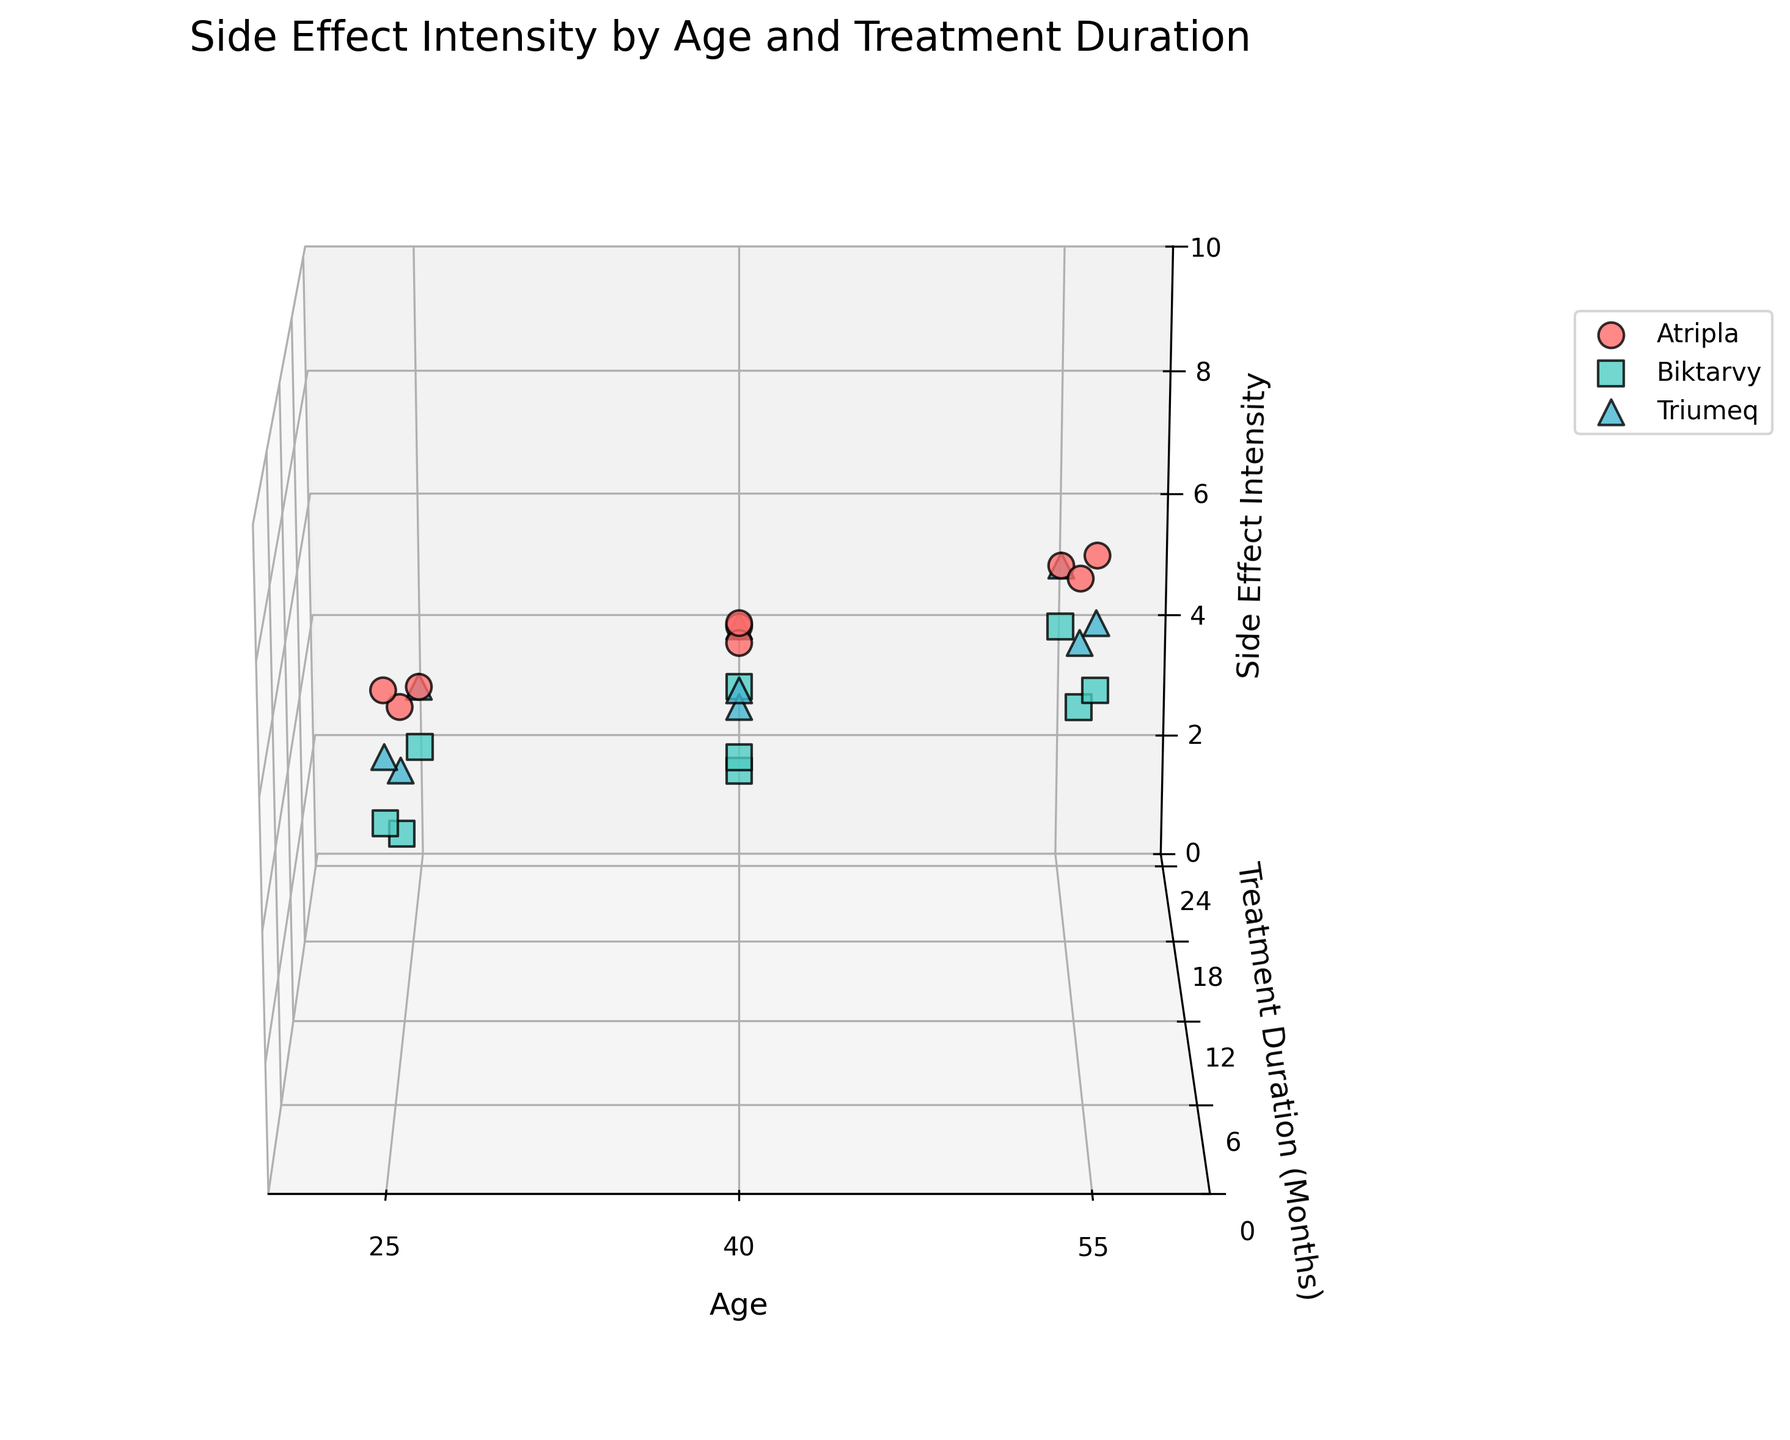What's the title of the figure? The title is typically placed at the top of the figure in a readable font size. The title of this figure is explicitly stated in the code as "Side Effect Intensity by Age and Treatment Duration."
Answer: Side Effect Intensity by Age and Treatment Duration What data does the x-axis represent? From the labels set in the code, the x-axis represents "Age" of the patients. This label helps to interpret what is being compared or measured.
Answer: Age What pattern can you observe with Side Effect Intensity over Treatment Duration for Atripla? The data suggests a decreasing trend of Side Effect Intensity over Treatment Duration for Atripla. Observing the plot points, Atripla shows higher side effect intensities at 3 months which decrease progressively over 12 and 24 months.
Answer: Decreasing trend Which medication seems to have the lowest overall Side Effect Intensity? By comparing the colored points, Biktarvy, represented by a specific color (e.g., turquoise), generally lies lower on the z-axis for all age groups and treatment durations.
Answer: Biktarvy How does the Side Effect Intensity for Triumeq change with the age of patients after 24 months of treatment? At 24 months, the z-coordinates for Triumeq's different ages (25, 40, 55) can be observed, which increase gradually as the age increases. This shows a pattern of side effects increasing with age.
Answer: Increases with age Which age group appears to be the most affected by Atripla in the early stage (3 months)? Look at the z-coordinates (Side Effect Intensity) for Atripla at 3 months across different ages. The 55-year-old group has the highest point, indicating they are most affected early on.
Answer: 55-year-olds What is the difference in Side Effect Intensity at 12 months between the youngest and oldest age groups for Biktarvy? For Biktarvy, note the z-values at 12 months for ages 25 and 55. The Side Effect Intensity for the 25-year-olds is 3, and for the 55-year-olds, it is 5. The difference is 5 - 3.
Answer: 2 Which medication shows the least variation in Side Effect Intensity over time for a given age group? By comparing the spread of each medication's z-values (Side Effect Intensity) over treatment durations, Biktarvy consistently shows the least variation, especially for any particular age group.
Answer: Biktarvy At what treatment duration do all medications have similar levels of Side Effect Intensity for the age group of 40? Observe the points for all medications at the age of 40 across different treatment durations. At 24 months, the points for all medications (Atripla, Biktarvy, Triumeq) are quite close vertically on the z-axis, indicating similar Side Effect Intensities.
Answer: 24 months What is the average Side Effect Intensity for Triumeq at 3 months across all age groups? Calculate the mean of Triumeq’s Side Effect Intensity at 3 months for ages 25, 40, and 55. The values are 6, 7, and 8 respectively. The average is (6 + 7 + 8) / 3.
Answer: 7 